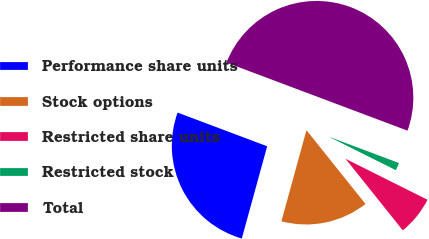Convert chart. <chart><loc_0><loc_0><loc_500><loc_500><pie_chart><fcel>Performance share units<fcel>Stock options<fcel>Restricted share units<fcel>Restricted stock<fcel>Total<nl><fcel>26.45%<fcel>15.01%<fcel>6.89%<fcel>1.65%<fcel>50.0%<nl></chart> 